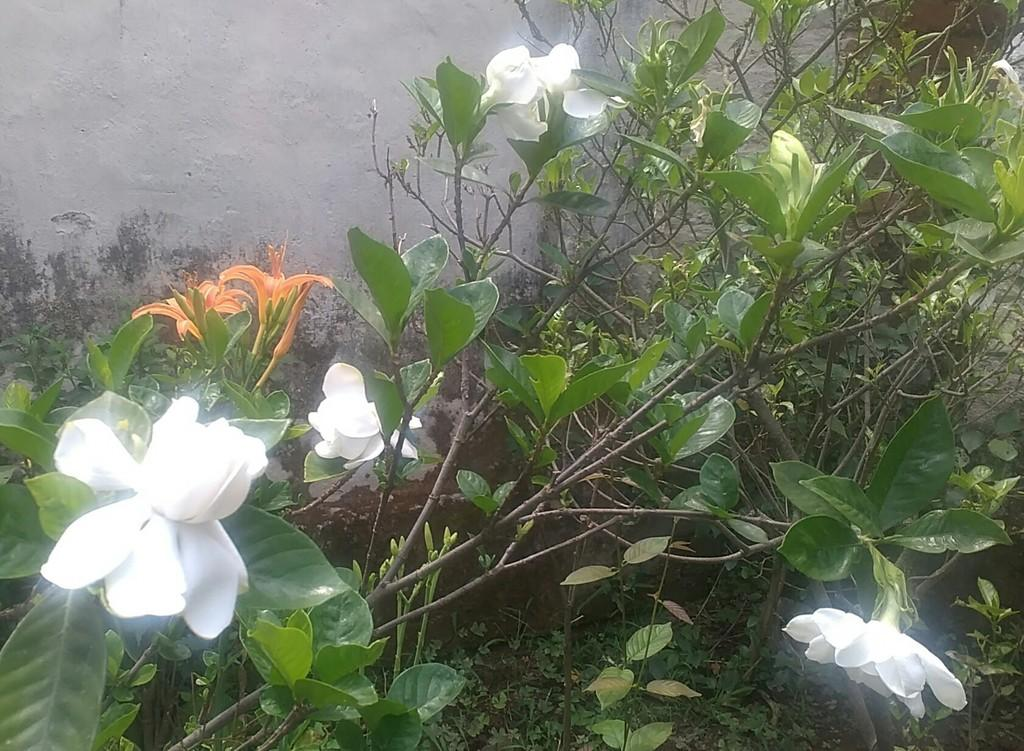What types of living organisms can be seen in the image? Plants and flowers are visible in the image. Can you describe the background of the image? There is a wall in the background of the image. What type of creature can be seen interacting with the plants in the image? There is no creature present in the image; it only features plants and flowers. What kind of picture is hanging on the wall in the background? There is no picture hanging on the wall in the background; only the wall itself is visible. 